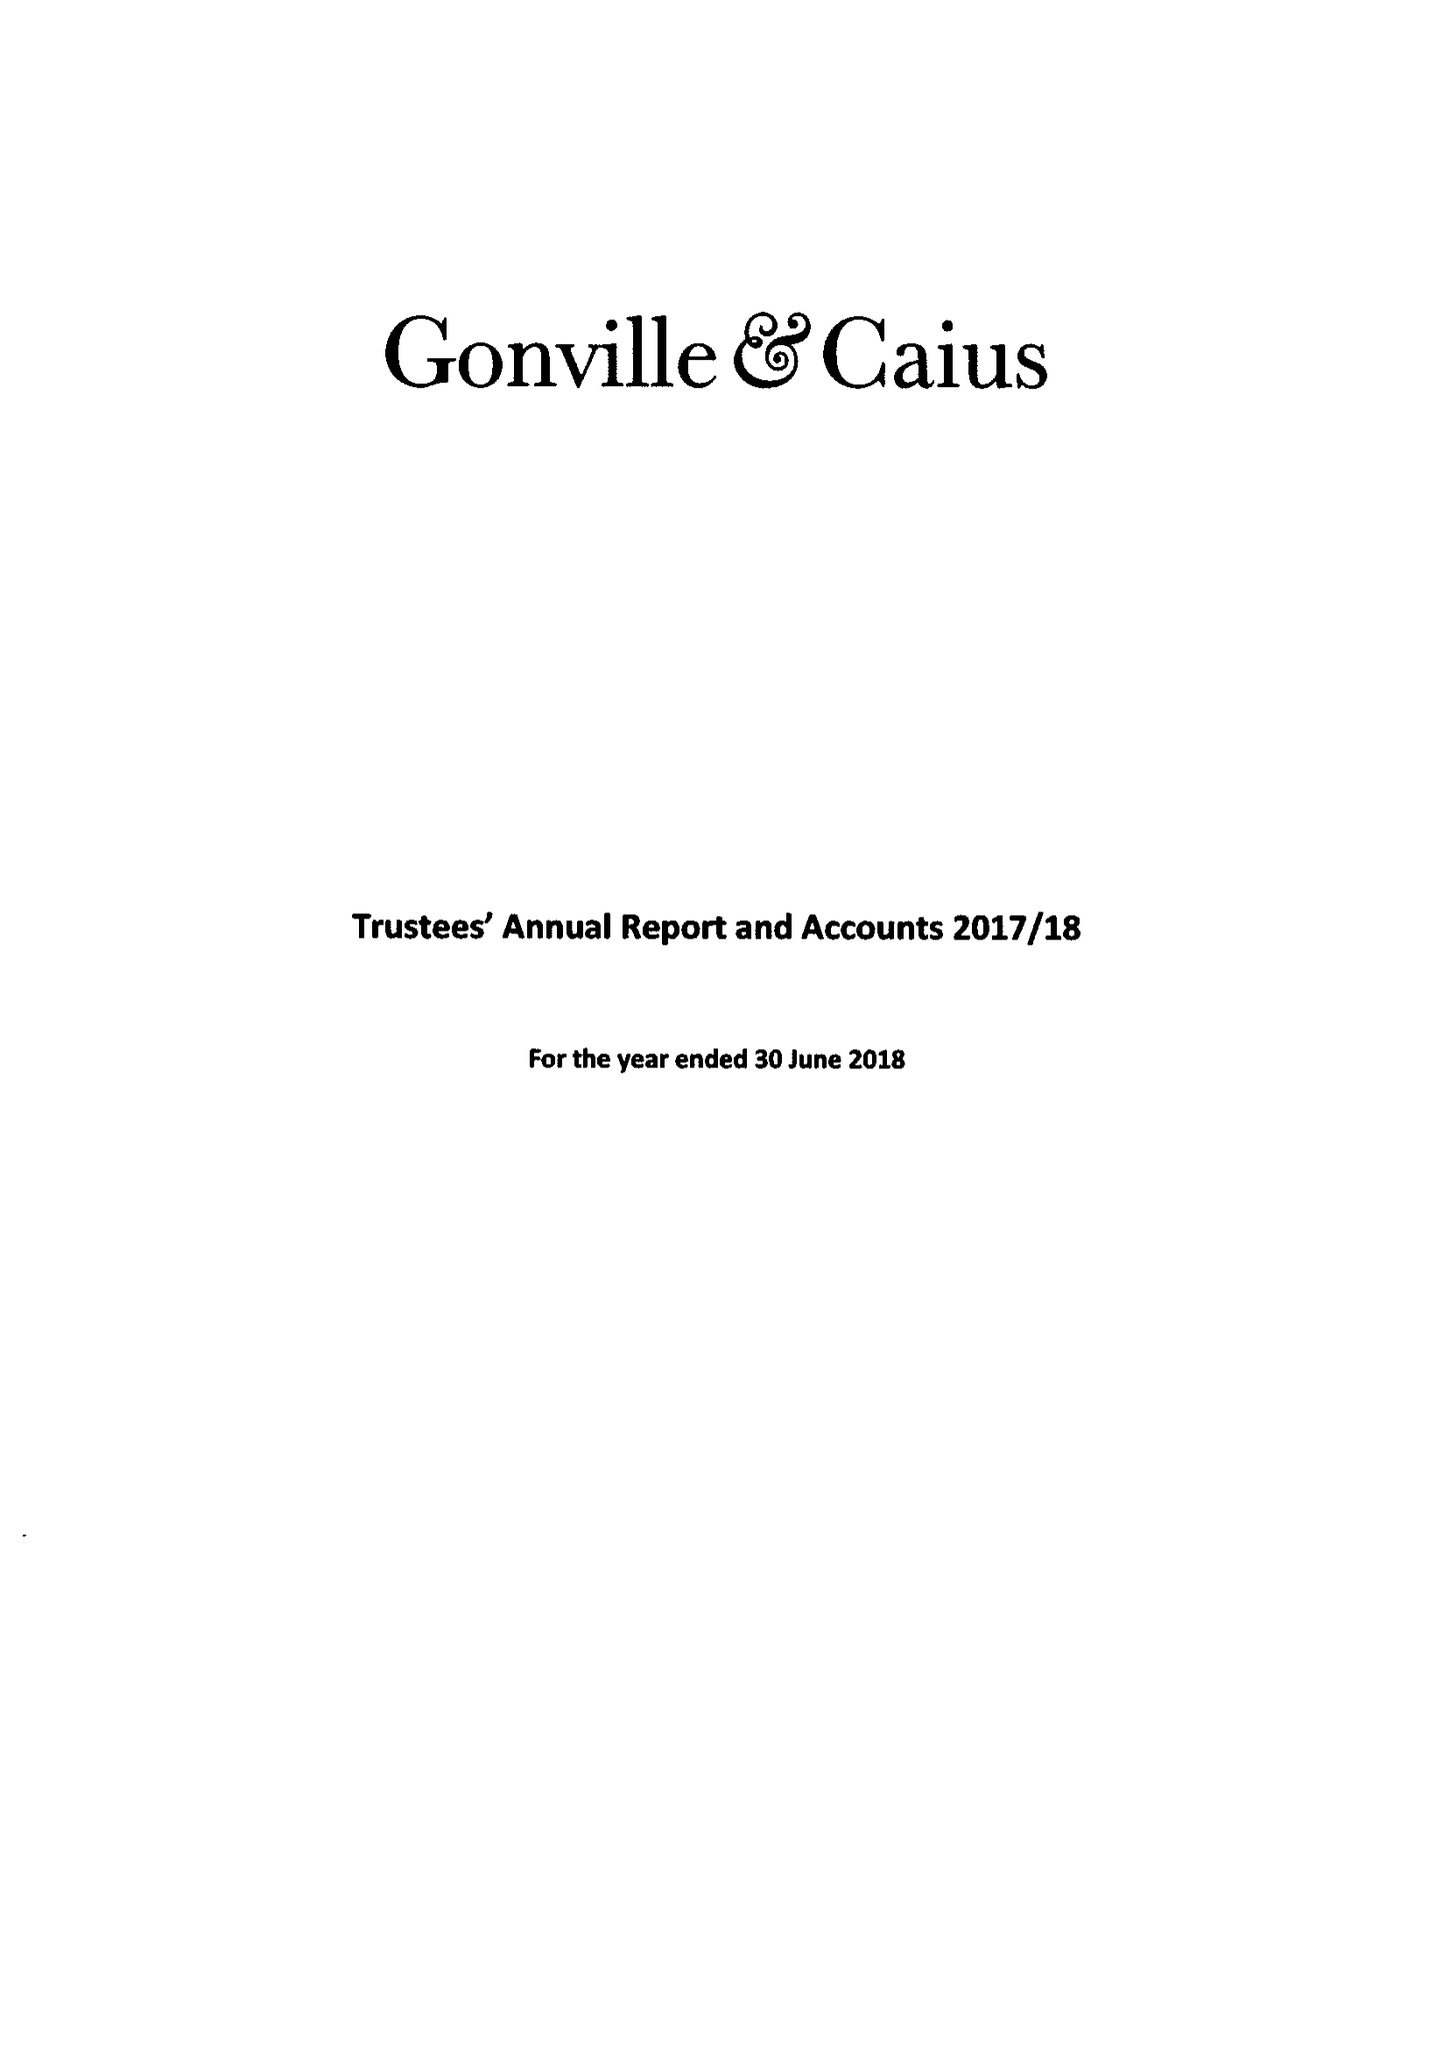What is the value for the spending_annually_in_british_pounds?
Answer the question using a single word or phrase. 16856000.00 